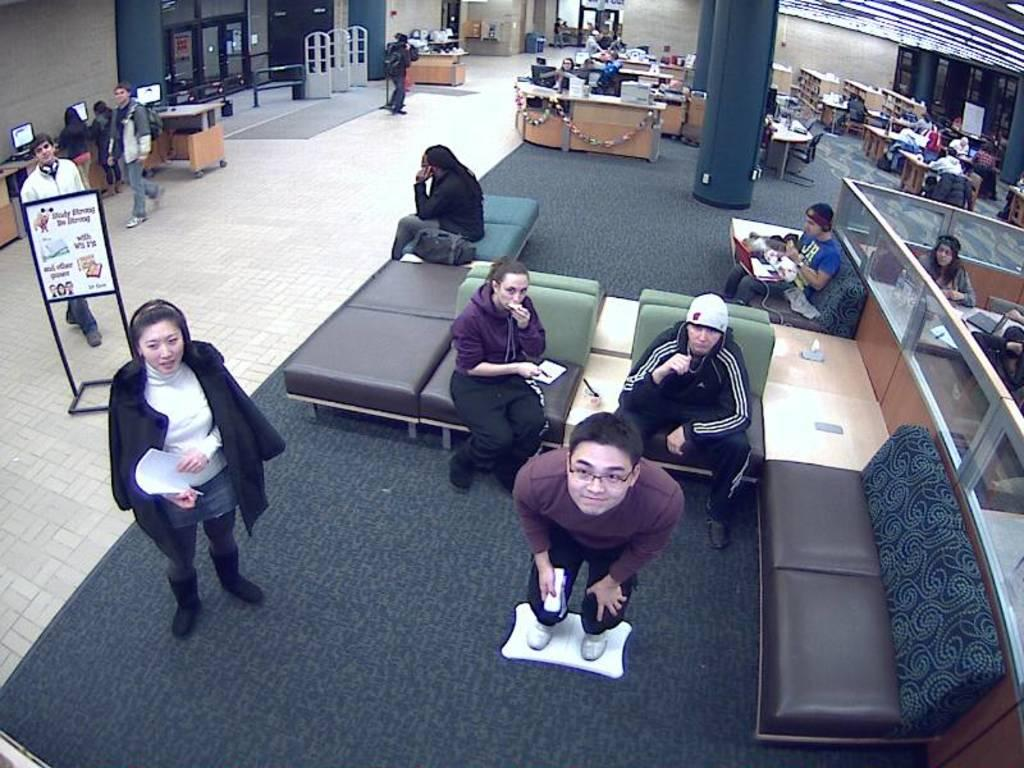What are the people in the image doing? There are people sitting on a sofa and people standing in the image. What can be seen in the background of the image? There are pillars, cabins, doors, and walls in the background. Where is the board located in the image? The board is on the left side of the image. What type of watch can be seen on the yoke in the image? There is no watch or yoke present in the image. 